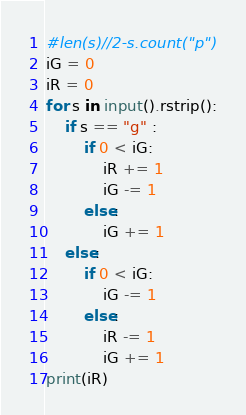Convert code to text. <code><loc_0><loc_0><loc_500><loc_500><_Python_>#len(s)//2-s.count("p")
iG = 0
iR = 0
for s in input().rstrip():
    if s == "g" :
        if 0 < iG:
            iR += 1
            iG -= 1
        else:
            iG += 1
    else:
        if 0 < iG:
            iG -= 1
        else:
            iR -= 1
            iG += 1
print(iR)
</code> 